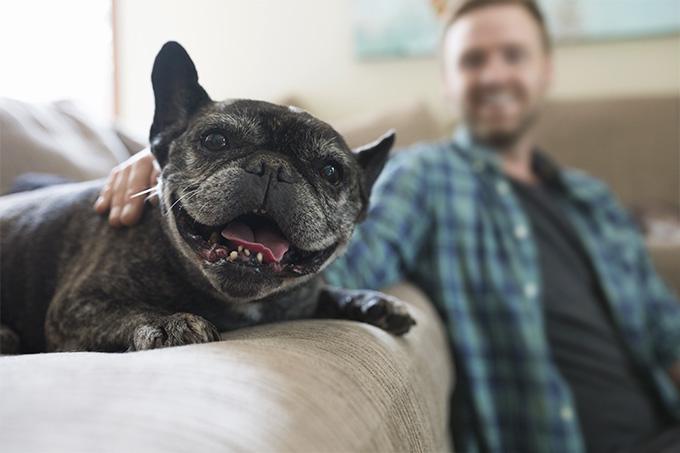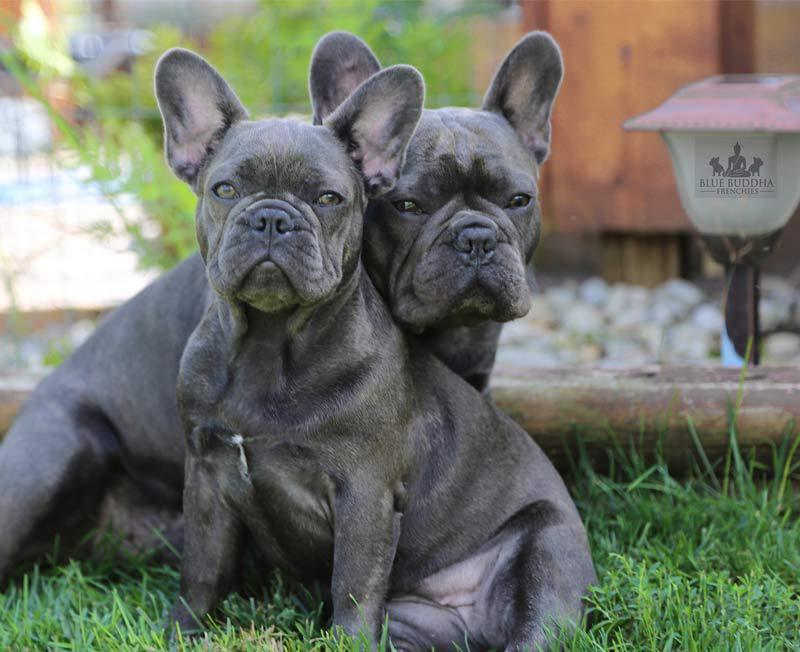The first image is the image on the left, the second image is the image on the right. Given the left and right images, does the statement "There are two dogs in the grass." hold true? Answer yes or no. Yes. The first image is the image on the left, the second image is the image on the right. Assess this claim about the two images: "All of the dogs are dark colored, and the right image contains twice the dogs as the left image.". Correct or not? Answer yes or no. Yes. 